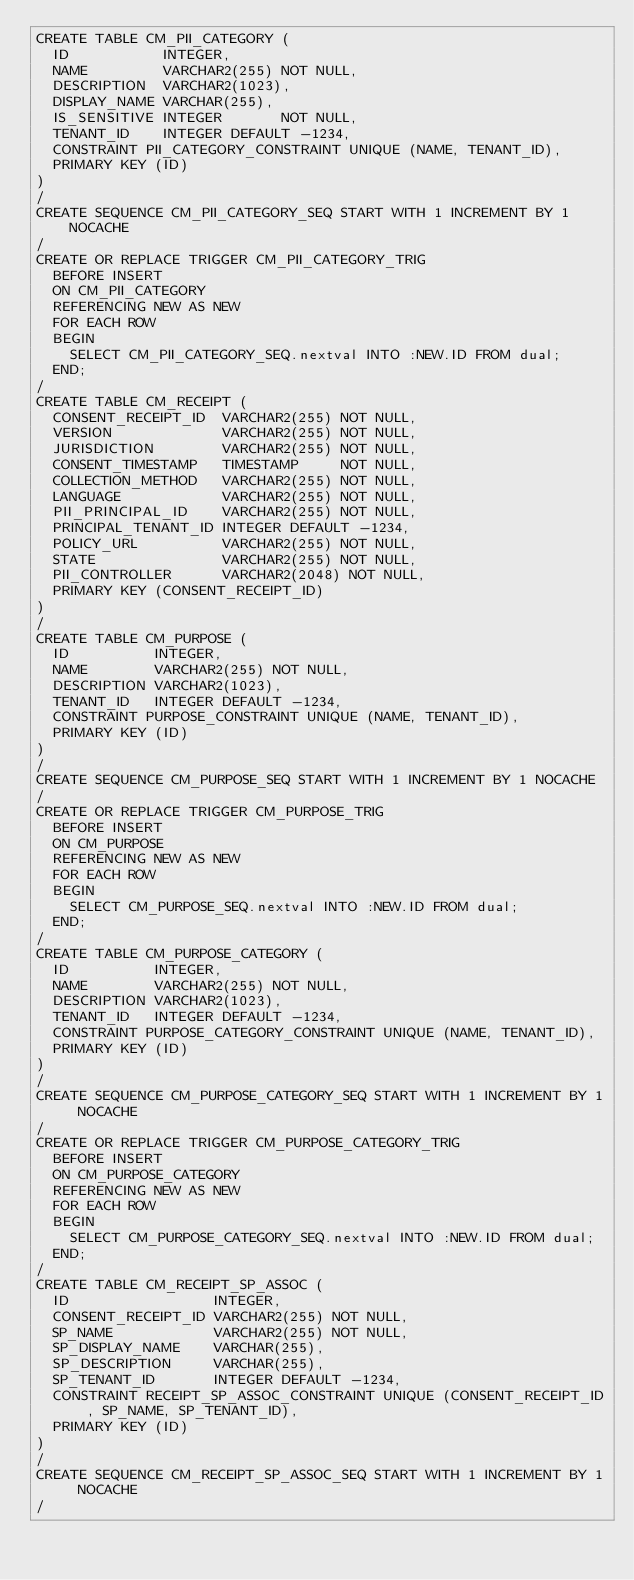Convert code to text. <code><loc_0><loc_0><loc_500><loc_500><_SQL_>CREATE TABLE CM_PII_CATEGORY (
  ID           INTEGER,
  NAME         VARCHAR2(255) NOT NULL,
  DESCRIPTION  VARCHAR2(1023),
  DISPLAY_NAME VARCHAR(255),
  IS_SENSITIVE INTEGER       NOT NULL,
  TENANT_ID    INTEGER DEFAULT -1234,
  CONSTRAINT PII_CATEGORY_CONSTRAINT UNIQUE (NAME, TENANT_ID),
  PRIMARY KEY (ID)
)
/
CREATE SEQUENCE CM_PII_CATEGORY_SEQ START WITH 1 INCREMENT BY 1 NOCACHE
/
CREATE OR REPLACE TRIGGER CM_PII_CATEGORY_TRIG
  BEFORE INSERT
  ON CM_PII_CATEGORY
  REFERENCING NEW AS NEW
  FOR EACH ROW
  BEGIN
    SELECT CM_PII_CATEGORY_SEQ.nextval INTO :NEW.ID FROM dual;
  END;
/
CREATE TABLE CM_RECEIPT (
  CONSENT_RECEIPT_ID  VARCHAR2(255) NOT NULL,
  VERSION             VARCHAR2(255) NOT NULL,
  JURISDICTION        VARCHAR2(255) NOT NULL,
  CONSENT_TIMESTAMP   TIMESTAMP     NOT NULL,
  COLLECTION_METHOD   VARCHAR2(255) NOT NULL,
  LANGUAGE            VARCHAR2(255) NOT NULL,
  PII_PRINCIPAL_ID    VARCHAR2(255) NOT NULL,
  PRINCIPAL_TENANT_ID INTEGER DEFAULT -1234,
  POLICY_URL          VARCHAR2(255) NOT NULL,
  STATE               VARCHAR2(255) NOT NULL,
  PII_CONTROLLER      VARCHAR2(2048) NOT NULL,
  PRIMARY KEY (CONSENT_RECEIPT_ID)
)
/
CREATE TABLE CM_PURPOSE (
  ID          INTEGER,
  NAME        VARCHAR2(255) NOT NULL,
  DESCRIPTION VARCHAR2(1023),
  TENANT_ID   INTEGER DEFAULT -1234,
  CONSTRAINT PURPOSE_CONSTRAINT UNIQUE (NAME, TENANT_ID),
  PRIMARY KEY (ID)
)
/
CREATE SEQUENCE CM_PURPOSE_SEQ START WITH 1 INCREMENT BY 1 NOCACHE
/
CREATE OR REPLACE TRIGGER CM_PURPOSE_TRIG
  BEFORE INSERT
  ON CM_PURPOSE
  REFERENCING NEW AS NEW
  FOR EACH ROW
  BEGIN
    SELECT CM_PURPOSE_SEQ.nextval INTO :NEW.ID FROM dual;
  END;
/
CREATE TABLE CM_PURPOSE_CATEGORY (
  ID          INTEGER,
  NAME        VARCHAR2(255) NOT NULL,
  DESCRIPTION VARCHAR2(1023),
  TENANT_ID   INTEGER DEFAULT -1234,
  CONSTRAINT PURPOSE_CATEGORY_CONSTRAINT UNIQUE (NAME, TENANT_ID),
  PRIMARY KEY (ID)
)
/
CREATE SEQUENCE CM_PURPOSE_CATEGORY_SEQ START WITH 1 INCREMENT BY 1 NOCACHE
/
CREATE OR REPLACE TRIGGER CM_PURPOSE_CATEGORY_TRIG
  BEFORE INSERT
  ON CM_PURPOSE_CATEGORY
  REFERENCING NEW AS NEW
  FOR EACH ROW
  BEGIN
    SELECT CM_PURPOSE_CATEGORY_SEQ.nextval INTO :NEW.ID FROM dual;
  END;
/
CREATE TABLE CM_RECEIPT_SP_ASSOC (
  ID                 INTEGER,
  CONSENT_RECEIPT_ID VARCHAR2(255) NOT NULL,
  SP_NAME            VARCHAR2(255) NOT NULL,
  SP_DISPLAY_NAME    VARCHAR(255),
  SP_DESCRIPTION     VARCHAR(255),
  SP_TENANT_ID       INTEGER DEFAULT -1234,
  CONSTRAINT RECEIPT_SP_ASSOC_CONSTRAINT UNIQUE (CONSENT_RECEIPT_ID, SP_NAME, SP_TENANT_ID),
  PRIMARY KEY (ID)
)
/
CREATE SEQUENCE CM_RECEIPT_SP_ASSOC_SEQ START WITH 1 INCREMENT BY 1 NOCACHE
/</code> 